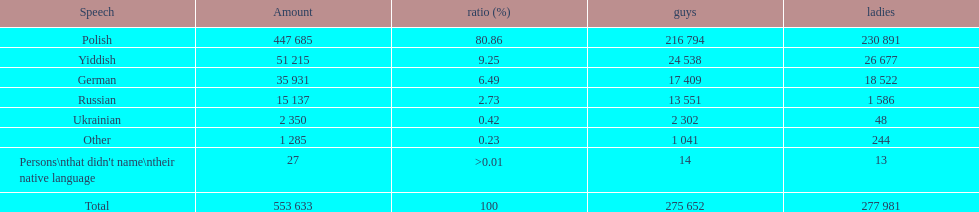How many male and female german speakers are there? 35931. 